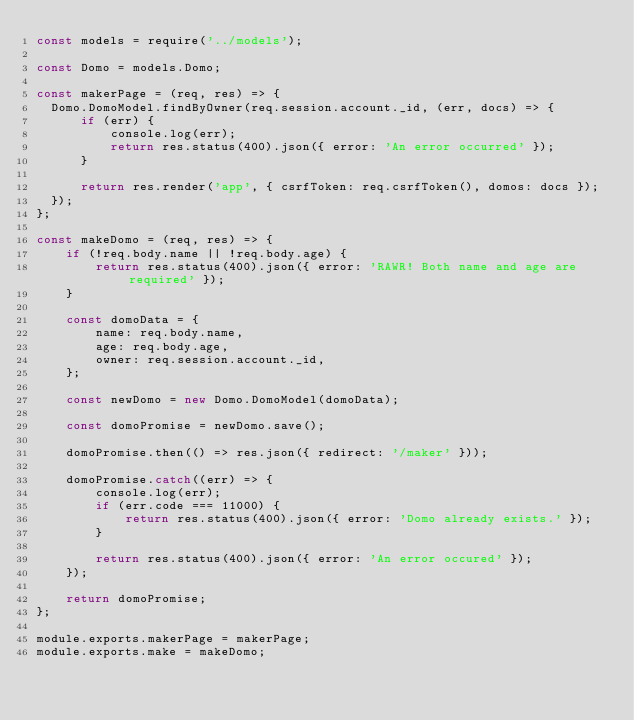<code> <loc_0><loc_0><loc_500><loc_500><_JavaScript_>const models = require('../models');

const Domo = models.Domo;

const makerPage = (req, res) => {
  Domo.DomoModel.findByOwner(req.session.account._id, (err, docs) => {
      if (err) {
          console.log(err);
          return res.status(400).json({ error: 'An error occurred' });
      }
      
      return res.render('app', { csrfToken: req.csrfToken(), domos: docs });
  });
};

const makeDomo = (req, res) => {
    if (!req.body.name || !req.body.age) {
        return res.status(400).json({ error: 'RAWR! Both name and age are required' });
    }
    
    const domoData = {
        name: req.body.name,
        age: req.body.age,
        owner: req.session.account._id,
    };
    
    const newDomo = new Domo.DomoModel(domoData);
    
    const domoPromise = newDomo.save();
    
    domoPromise.then(() => res.json({ redirect: '/maker' }));
    
    domoPromise.catch((err) => {
        console.log(err);
        if (err.code === 11000) {
            return res.status(400).json({ error: 'Domo already exists.' });
        }
        
        return res.status(400).json({ error: 'An error occured' });
    });
    
    return domoPromise;
};

module.exports.makerPage = makerPage;
module.exports.make = makeDomo;</code> 